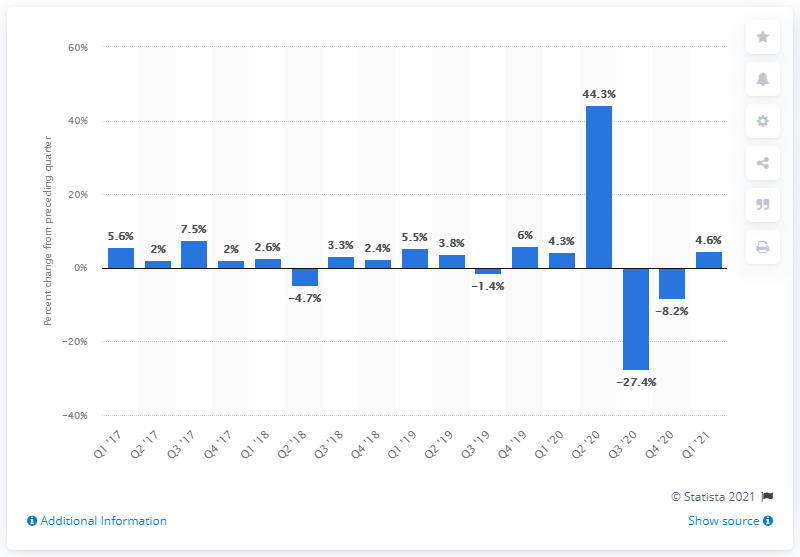Mention a couple of crucial points in this snapshot. In the first quarter of 2021, the cost of labor for manufacturing units increased by 4.6%. 